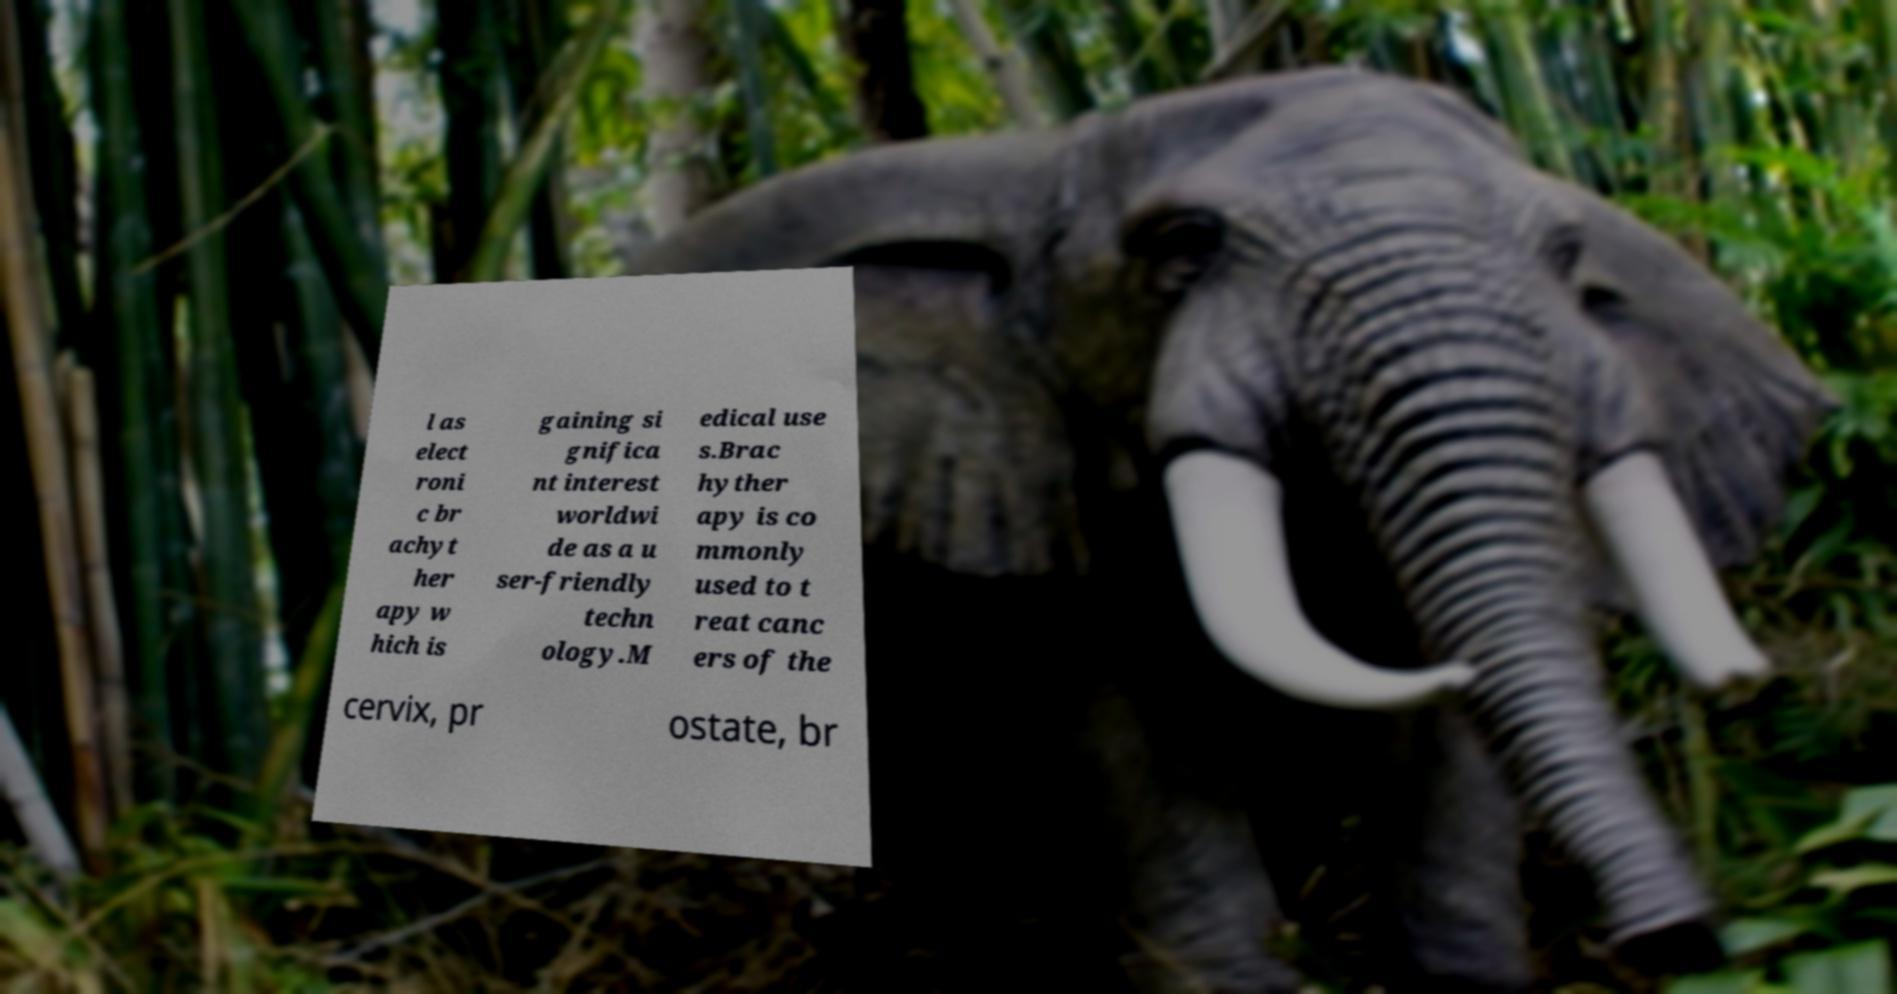I need the written content from this picture converted into text. Can you do that? l as elect roni c br achyt her apy w hich is gaining si gnifica nt interest worldwi de as a u ser-friendly techn ology.M edical use s.Brac hyther apy is co mmonly used to t reat canc ers of the cervix, pr ostate, br 